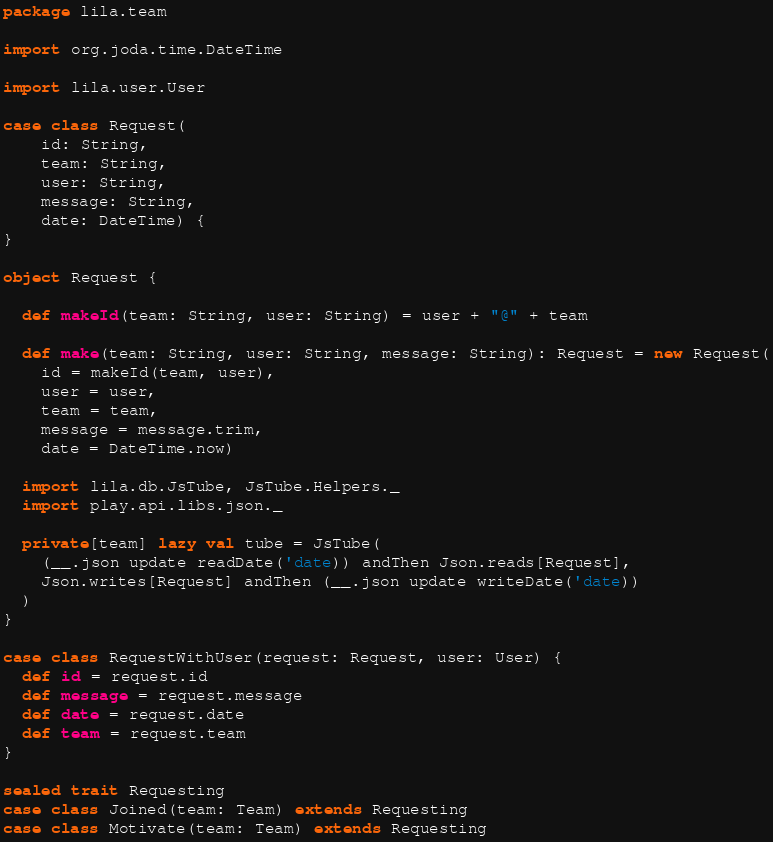Convert code to text. <code><loc_0><loc_0><loc_500><loc_500><_Scala_>package lila.team

import org.joda.time.DateTime

import lila.user.User

case class Request(
    id: String,
    team: String,
    user: String,
    message: String,
    date: DateTime) {
}

object Request {

  def makeId(team: String, user: String) = user + "@" + team

  def make(team: String, user: String, message: String): Request = new Request(
    id = makeId(team, user),
    user = user,
    team = team,
    message = message.trim,
    date = DateTime.now)

  import lila.db.JsTube, JsTube.Helpers._
  import play.api.libs.json._

  private[team] lazy val tube = JsTube(
    (__.json update readDate('date)) andThen Json.reads[Request],
    Json.writes[Request] andThen (__.json update writeDate('date))
  ) 
}

case class RequestWithUser(request: Request, user: User) {
  def id = request.id
  def message = request.message
  def date = request.date
  def team = request.team
}

sealed trait Requesting
case class Joined(team: Team) extends Requesting
case class Motivate(team: Team) extends Requesting
</code> 